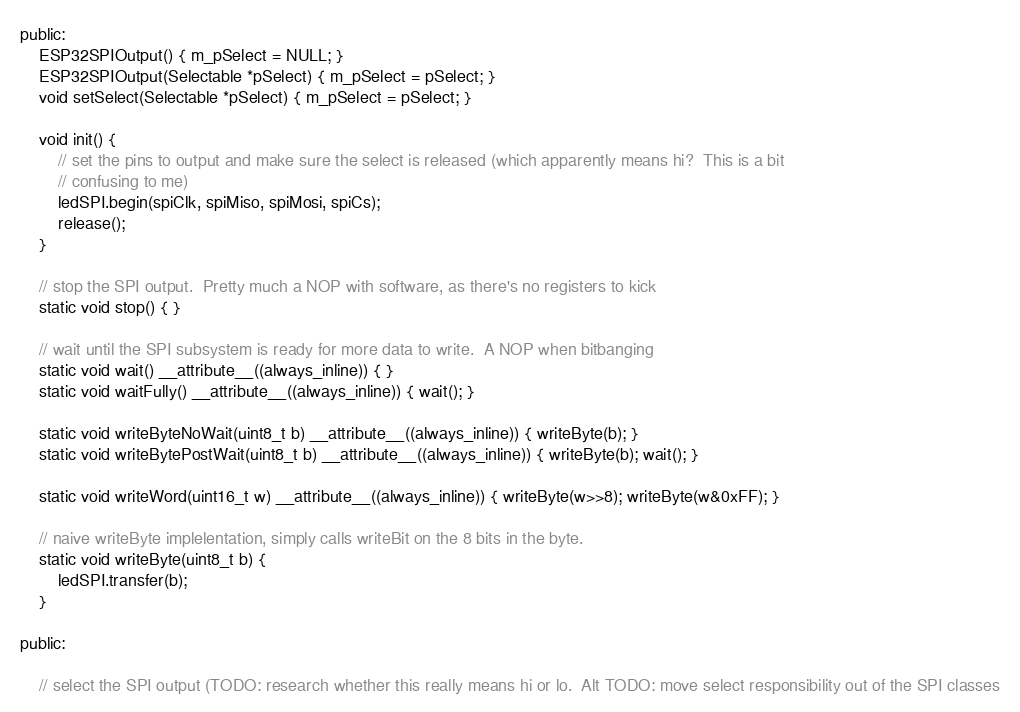<code> <loc_0><loc_0><loc_500><loc_500><_C_>
public:
	ESP32SPIOutput() { m_pSelect = NULL; }
	ESP32SPIOutput(Selectable *pSelect) { m_pSelect = pSelect; }
	void setSelect(Selectable *pSelect) { m_pSelect = pSelect; }

	void init() {
		// set the pins to output and make sure the select is released (which apparently means hi?  This is a bit
		// confusing to me)
		ledSPI.begin(spiClk, spiMiso, spiMosi, spiCs);
		release();
	}

	// stop the SPI output.  Pretty much a NOP with software, as there's no registers to kick
	static void stop() { }

	// wait until the SPI subsystem is ready for more data to write.  A NOP when bitbanging
	static void wait() __attribute__((always_inline)) { }
	static void waitFully() __attribute__((always_inline)) { wait(); }

	static void writeByteNoWait(uint8_t b) __attribute__((always_inline)) { writeByte(b); }
	static void writeBytePostWait(uint8_t b) __attribute__((always_inline)) { writeByte(b); wait(); }

	static void writeWord(uint16_t w) __attribute__((always_inline)) { writeByte(w>>8); writeByte(w&0xFF); }

	// naive writeByte implelentation, simply calls writeBit on the 8 bits in the byte.
	static void writeByte(uint8_t b) {
		ledSPI.transfer(b);
	}

public:

	// select the SPI output (TODO: research whether this really means hi or lo.  Alt TODO: move select responsibility out of the SPI classes</code> 